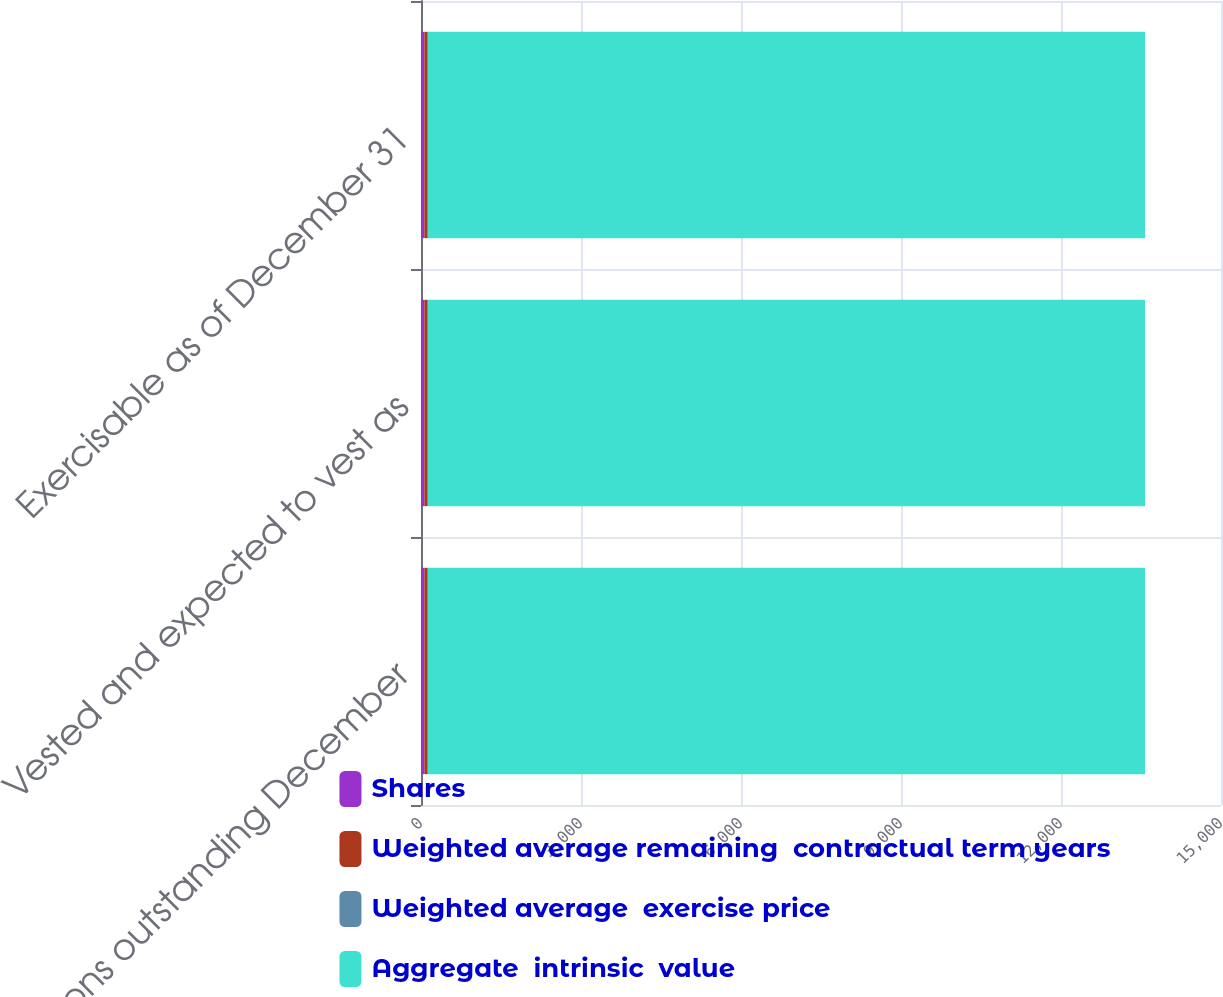<chart> <loc_0><loc_0><loc_500><loc_500><stacked_bar_chart><ecel><fcel>Options outstanding December<fcel>Vested and expected to vest as<fcel>Exercisable as of December 31<nl><fcel>Shares<fcel>63<fcel>63<fcel>63<nl><fcel>Weighted average remaining  contractual term years<fcel>62.86<fcel>62.86<fcel>62.86<nl><fcel>Weighted average  exercise price<fcel>3.8<fcel>3.8<fcel>3.8<nl><fcel>Aggregate  intrinsic  value<fcel>13446<fcel>13446<fcel>13446<nl></chart> 